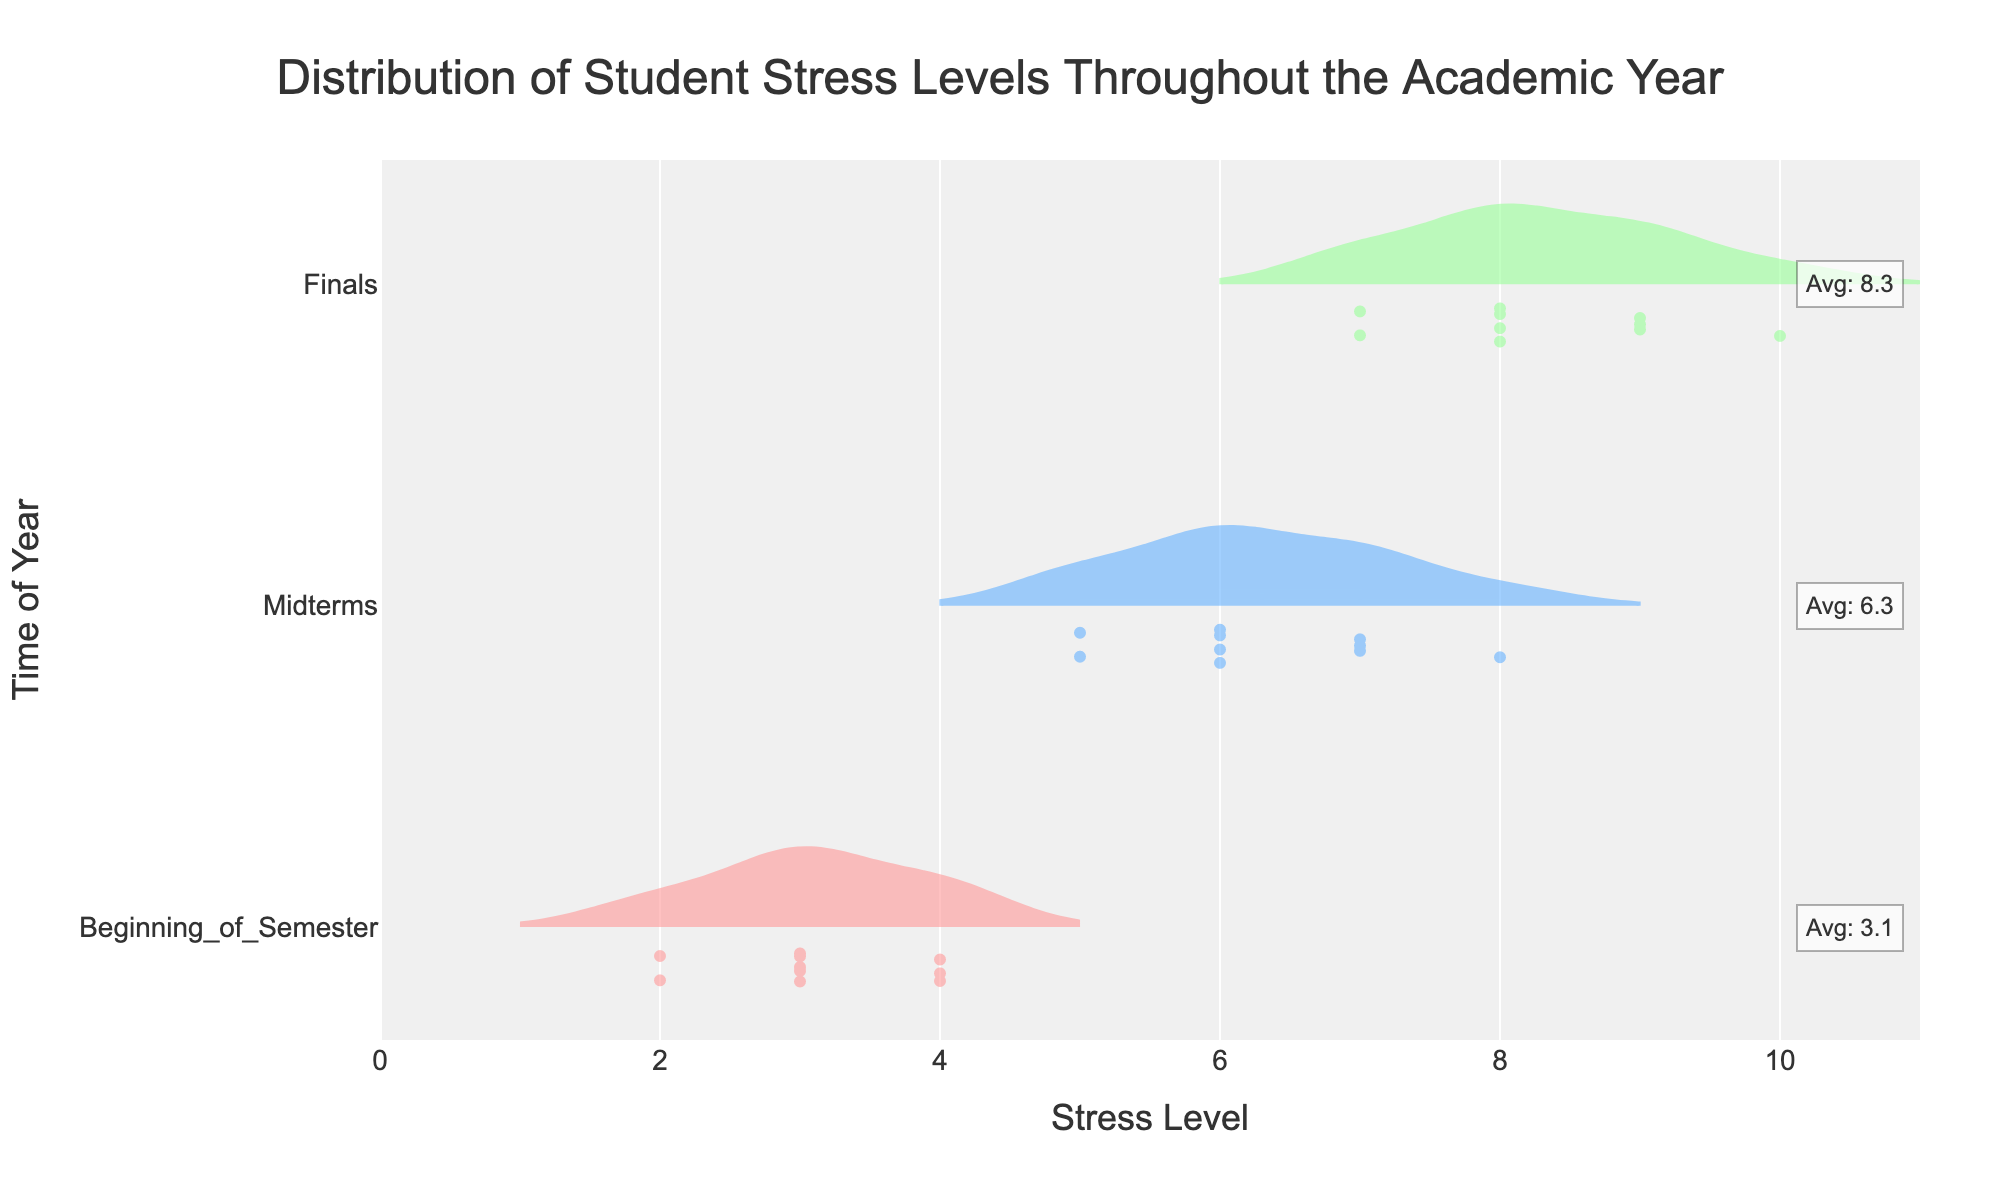What is the title of the chart? The title is usually displayed at the top of the chart. It clearly states the main topic being visualized. In this case, it is "Distribution of Student Stress Levels Throughout the Academic Year".
Answer: Distribution of Student Stress Levels Throughout the Academic Year What is the average stress level during Midterms? The chart often includes annotations for the average stress level for each period. The annotation for Midterms indicates the average stress level.
Answer: 6.3 Which time of the year has the widest distribution of stress levels? The width of the violin plot indicates the distribution of the stress levels. The widest violin plot shows the largest variation.
Answer: Finals Where is the median stress level for 'Beginning of Semester' located in terms of stress level? Violin plots often show a line representing the median. For 'Beginning of Semester', this line is located at the stress level where the plot takes its median value.
Answer: 3 How many students reported a stress level of 9 during Finals? Data points are represented by dots on the violin plot. Count the number of dots corresponding to a stress level of 9 in the 'Finals' plot.
Answer: 3 What is the minimum stress level observed at the Beginning of the Semester? The bottom point of the violin plot represents the minimum value in the dataset for that time. For 'Beginning of Semester', see where the plot starts on the lower side.
Answer: 2 How does the average stress level change from the Beginning of Semester to Finals? To find the change, compare the annotations of the average stress levels for both 'Beginning of Semester' and 'Finals'. The average stress level increases from one to the other.
Answer: It increases from 3.25 to 8 Which time of the year shows the maximum average stress level? Look at the annotations for the average stress levels for each time period and identify the maximum value.
Answer: Finals Comparing 'Midterms' and 'Finals', which time has a higher median stress level? The median is represented by a horizontal line in the violin plot. Compare the positions of these lines between 'Midterms' and 'Finals'.
Answer: Finals Which time of the year has the smallest interquartile range of stress levels? The interquartile range (IQR) can be deduced by the width of the box in the box plot within the violin. The smallest IQR will have the shortest width between the first and third quartiles.
Answer: Midterms 